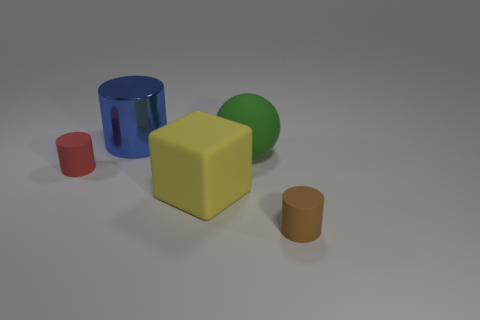There is a small rubber thing that is to the right of the big blue metal object; does it have the same shape as the tiny object that is left of the block? yes 